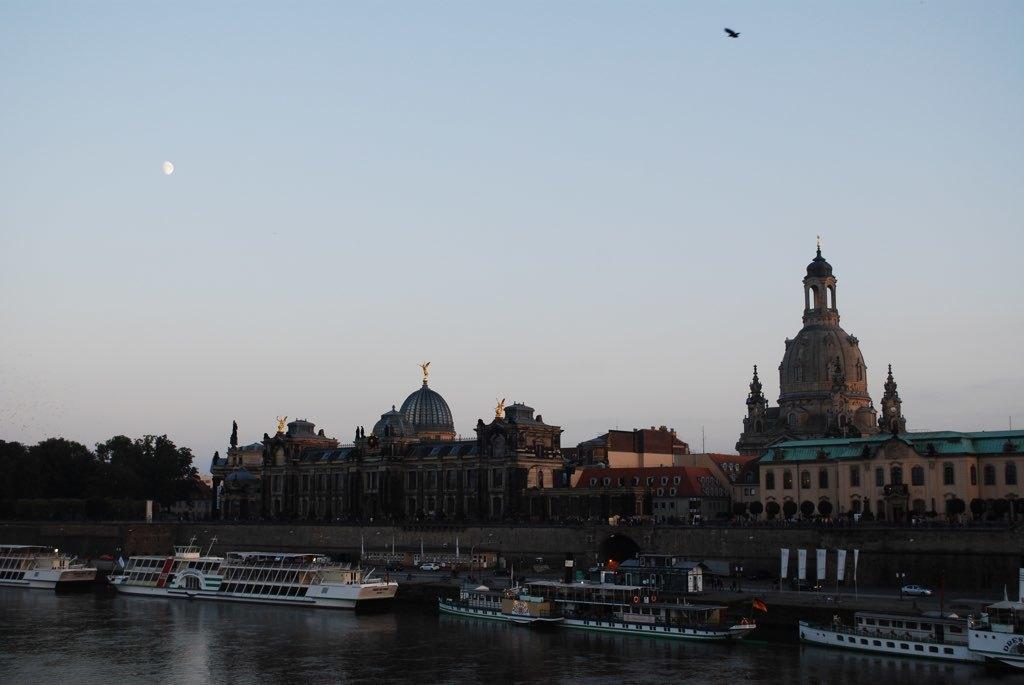Can you describe this image briefly? In this image there are buildings and trees. At the bottom there is water and we can see boats on the water. In the background there is sky and we can see a bird in the sky. 